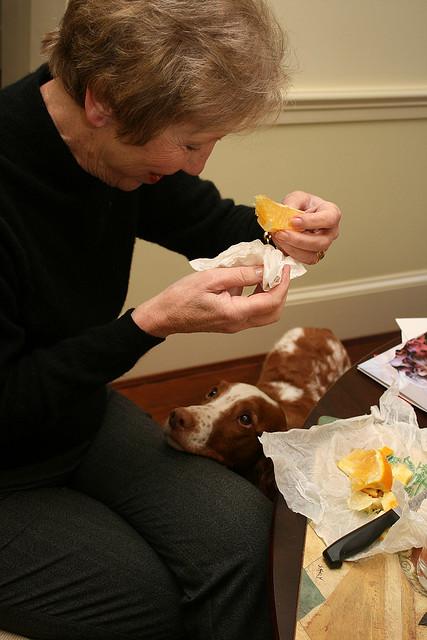Is the dog begging?
Write a very short answer. Yes. Is the dog eating?
Write a very short answer. No. What is the person eating?
Quick response, please. Orange. 